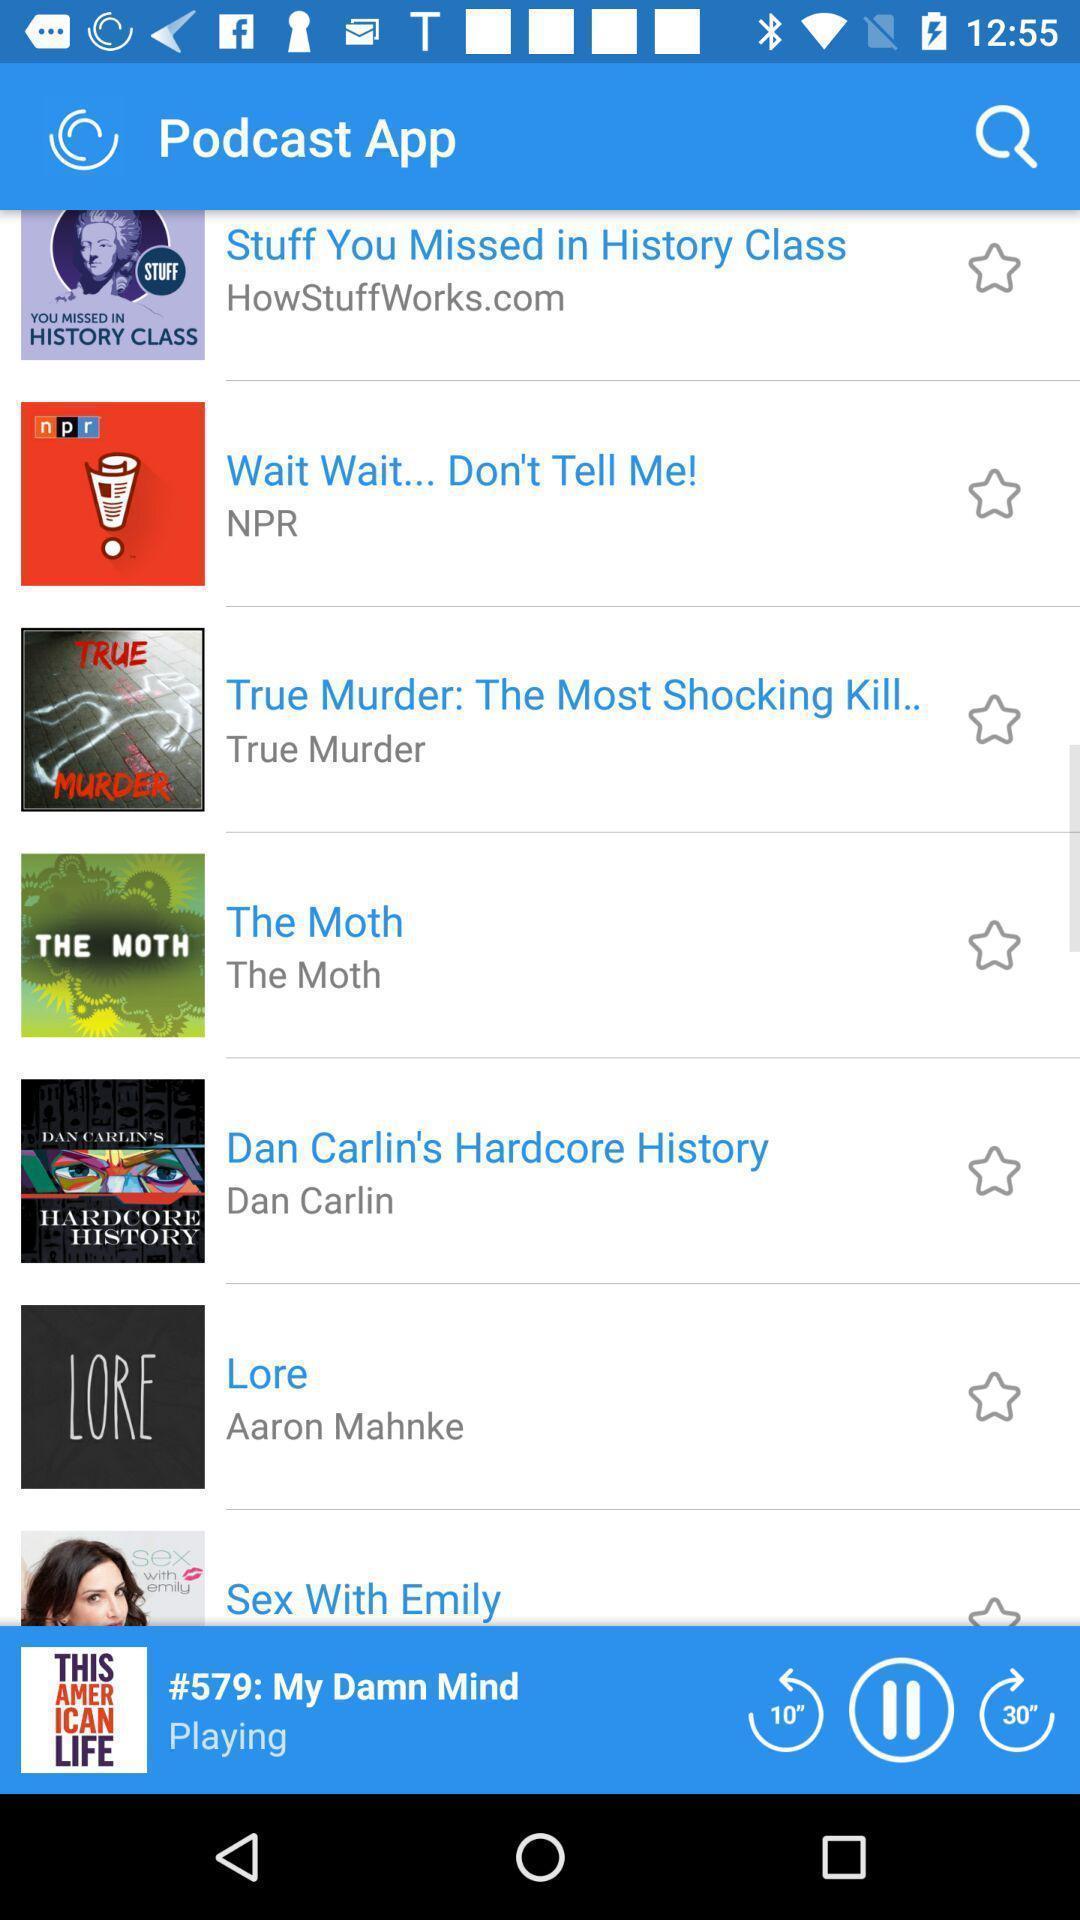Tell me about the visual elements in this screen capture. Screen shows about a podcast app. 